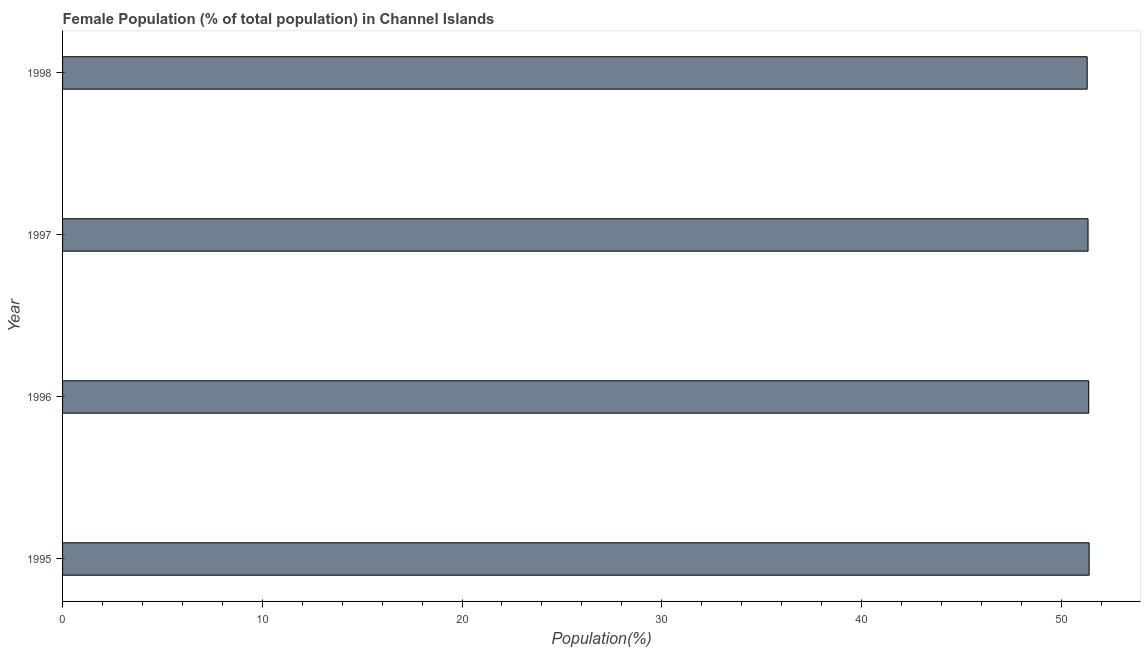Does the graph contain grids?
Provide a succinct answer. No. What is the title of the graph?
Keep it short and to the point. Female Population (% of total population) in Channel Islands. What is the label or title of the X-axis?
Keep it short and to the point. Population(%). What is the female population in 1998?
Your response must be concise. 51.3. Across all years, what is the maximum female population?
Make the answer very short. 51.4. Across all years, what is the minimum female population?
Keep it short and to the point. 51.3. In which year was the female population maximum?
Keep it short and to the point. 1995. What is the sum of the female population?
Keep it short and to the point. 205.41. What is the difference between the female population in 1995 and 1998?
Make the answer very short. 0.1. What is the average female population per year?
Give a very brief answer. 51.35. What is the median female population?
Your answer should be compact. 51.36. In how many years, is the female population greater than 4 %?
Your response must be concise. 4. Is the female population in 1995 less than that in 1996?
Offer a terse response. No. Is the difference between the female population in 1995 and 1997 greater than the difference between any two years?
Provide a succinct answer. No. What is the difference between the highest and the second highest female population?
Offer a very short reply. 0.02. What is the difference between the highest and the lowest female population?
Provide a short and direct response. 0.1. Are all the bars in the graph horizontal?
Ensure brevity in your answer.  Yes. What is the difference between two consecutive major ticks on the X-axis?
Your response must be concise. 10. What is the Population(%) of 1995?
Offer a terse response. 51.4. What is the Population(%) in 1996?
Offer a terse response. 51.38. What is the Population(%) of 1997?
Your response must be concise. 51.34. What is the Population(%) of 1998?
Offer a terse response. 51.3. What is the difference between the Population(%) in 1995 and 1996?
Make the answer very short. 0.02. What is the difference between the Population(%) in 1995 and 1997?
Provide a succinct answer. 0.06. What is the difference between the Population(%) in 1995 and 1998?
Your answer should be very brief. 0.1. What is the difference between the Population(%) in 1996 and 1997?
Give a very brief answer. 0.03. What is the difference between the Population(%) in 1996 and 1998?
Ensure brevity in your answer.  0.08. What is the difference between the Population(%) in 1997 and 1998?
Give a very brief answer. 0.04. What is the ratio of the Population(%) in 1995 to that in 1996?
Provide a succinct answer. 1. What is the ratio of the Population(%) in 1995 to that in 1997?
Your answer should be very brief. 1. What is the ratio of the Population(%) in 1996 to that in 1997?
Make the answer very short. 1. What is the ratio of the Population(%) in 1996 to that in 1998?
Offer a very short reply. 1. What is the ratio of the Population(%) in 1997 to that in 1998?
Make the answer very short. 1. 